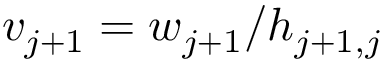Convert formula to latex. <formula><loc_0><loc_0><loc_500><loc_500>v _ { j + 1 } = w _ { j + 1 } / h _ { j + 1 , j }</formula> 